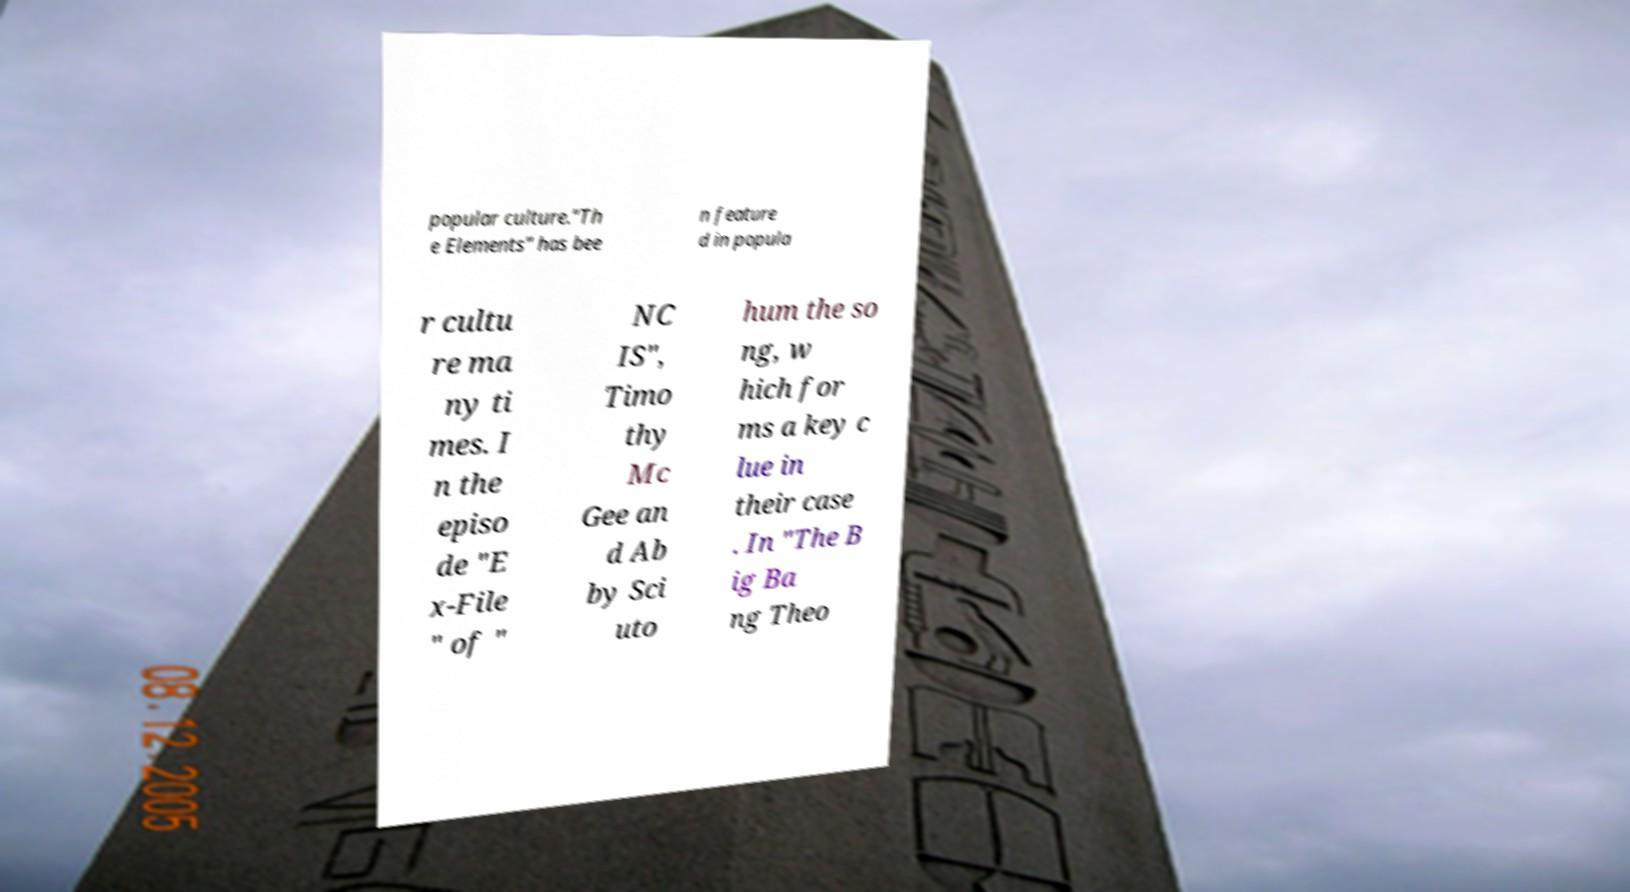There's text embedded in this image that I need extracted. Can you transcribe it verbatim? popular culture."Th e Elements" has bee n feature d in popula r cultu re ma ny ti mes. I n the episo de "E x-File " of " NC IS", Timo thy Mc Gee an d Ab by Sci uto hum the so ng, w hich for ms a key c lue in their case . In "The B ig Ba ng Theo 